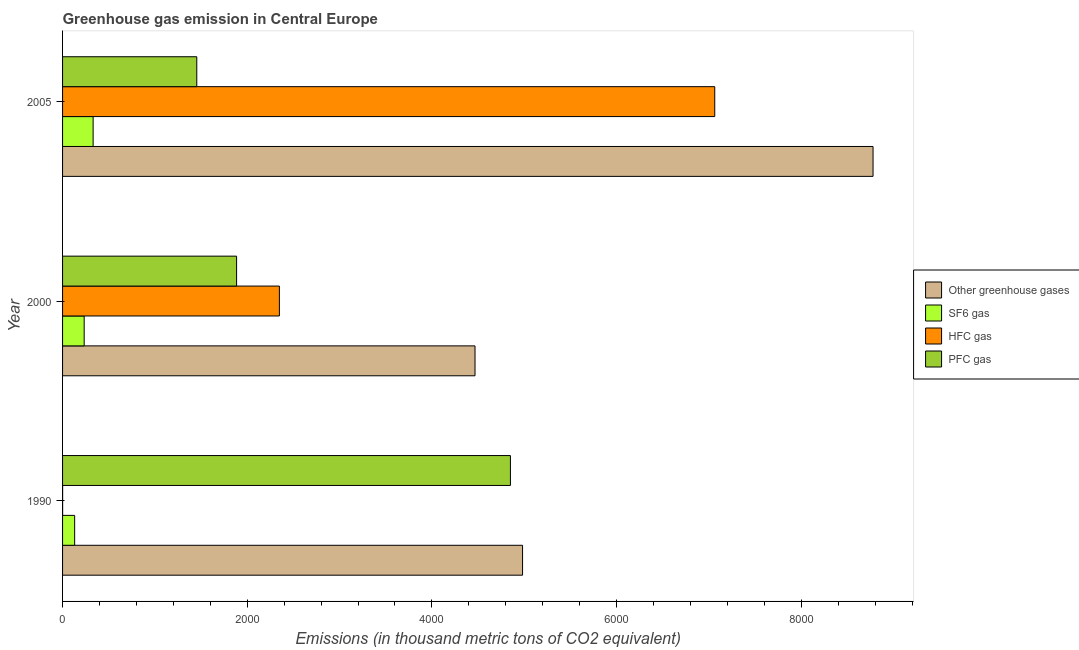How many different coloured bars are there?
Make the answer very short. 4. Are the number of bars on each tick of the Y-axis equal?
Your response must be concise. Yes. How many bars are there on the 2nd tick from the bottom?
Keep it short and to the point. 4. In how many cases, is the number of bars for a given year not equal to the number of legend labels?
Offer a very short reply. 0. What is the emission of hfc gas in 1990?
Your answer should be very brief. 0.5. Across all years, what is the maximum emission of sf6 gas?
Ensure brevity in your answer.  330.99. Across all years, what is the minimum emission of pfc gas?
Ensure brevity in your answer.  1453.6. In which year was the emission of hfc gas maximum?
Ensure brevity in your answer.  2005. What is the total emission of sf6 gas in the graph?
Offer a terse response. 695.99. What is the difference between the emission of greenhouse gases in 1990 and that in 2000?
Your answer should be compact. 515. What is the difference between the emission of sf6 gas in 2000 and the emission of greenhouse gases in 2005?
Provide a succinct answer. -8543.6. What is the average emission of hfc gas per year?
Ensure brevity in your answer.  3137.33. In the year 2000, what is the difference between the emission of hfc gas and emission of greenhouse gases?
Give a very brief answer. -2118.7. What is the ratio of the emission of sf6 gas in 1990 to that in 2005?
Keep it short and to the point. 0.4. What is the difference between the highest and the second highest emission of pfc gas?
Your response must be concise. 2965.7. What is the difference between the highest and the lowest emission of pfc gas?
Your answer should be compact. 3396.8. Is the sum of the emission of pfc gas in 1990 and 2000 greater than the maximum emission of hfc gas across all years?
Your answer should be very brief. No. Is it the case that in every year, the sum of the emission of greenhouse gases and emission of sf6 gas is greater than the sum of emission of pfc gas and emission of hfc gas?
Your answer should be very brief. Yes. What does the 2nd bar from the top in 1990 represents?
Provide a succinct answer. HFC gas. What does the 3rd bar from the bottom in 1990 represents?
Make the answer very short. HFC gas. Is it the case that in every year, the sum of the emission of greenhouse gases and emission of sf6 gas is greater than the emission of hfc gas?
Your answer should be very brief. Yes. How many years are there in the graph?
Your response must be concise. 3. Does the graph contain any zero values?
Provide a succinct answer. No. Does the graph contain grids?
Your answer should be very brief. No. How are the legend labels stacked?
Make the answer very short. Vertical. What is the title of the graph?
Offer a very short reply. Greenhouse gas emission in Central Europe. Does "UNDP" appear as one of the legend labels in the graph?
Give a very brief answer. No. What is the label or title of the X-axis?
Offer a terse response. Emissions (in thousand metric tons of CO2 equivalent). What is the label or title of the Y-axis?
Provide a short and direct response. Year. What is the Emissions (in thousand metric tons of CO2 equivalent) of Other greenhouse gases in 1990?
Your response must be concise. 4981.9. What is the Emissions (in thousand metric tons of CO2 equivalent) of SF6 gas in 1990?
Your answer should be compact. 131. What is the Emissions (in thousand metric tons of CO2 equivalent) of HFC gas in 1990?
Ensure brevity in your answer.  0.5. What is the Emissions (in thousand metric tons of CO2 equivalent) in PFC gas in 1990?
Your answer should be compact. 4850.4. What is the Emissions (in thousand metric tons of CO2 equivalent) in Other greenhouse gases in 2000?
Your response must be concise. 4466.9. What is the Emissions (in thousand metric tons of CO2 equivalent) in SF6 gas in 2000?
Your answer should be very brief. 234. What is the Emissions (in thousand metric tons of CO2 equivalent) in HFC gas in 2000?
Your answer should be compact. 2348.2. What is the Emissions (in thousand metric tons of CO2 equivalent) of PFC gas in 2000?
Make the answer very short. 1884.7. What is the Emissions (in thousand metric tons of CO2 equivalent) in Other greenhouse gases in 2005?
Provide a succinct answer. 8777.6. What is the Emissions (in thousand metric tons of CO2 equivalent) of SF6 gas in 2005?
Keep it short and to the point. 330.99. What is the Emissions (in thousand metric tons of CO2 equivalent) of HFC gas in 2005?
Give a very brief answer. 7063.3. What is the Emissions (in thousand metric tons of CO2 equivalent) of PFC gas in 2005?
Provide a short and direct response. 1453.6. Across all years, what is the maximum Emissions (in thousand metric tons of CO2 equivalent) in Other greenhouse gases?
Ensure brevity in your answer.  8777.6. Across all years, what is the maximum Emissions (in thousand metric tons of CO2 equivalent) in SF6 gas?
Your answer should be very brief. 330.99. Across all years, what is the maximum Emissions (in thousand metric tons of CO2 equivalent) in HFC gas?
Offer a very short reply. 7063.3. Across all years, what is the maximum Emissions (in thousand metric tons of CO2 equivalent) in PFC gas?
Your answer should be very brief. 4850.4. Across all years, what is the minimum Emissions (in thousand metric tons of CO2 equivalent) of Other greenhouse gases?
Keep it short and to the point. 4466.9. Across all years, what is the minimum Emissions (in thousand metric tons of CO2 equivalent) in SF6 gas?
Your answer should be very brief. 131. Across all years, what is the minimum Emissions (in thousand metric tons of CO2 equivalent) of PFC gas?
Your response must be concise. 1453.6. What is the total Emissions (in thousand metric tons of CO2 equivalent) in Other greenhouse gases in the graph?
Make the answer very short. 1.82e+04. What is the total Emissions (in thousand metric tons of CO2 equivalent) in SF6 gas in the graph?
Offer a terse response. 695.99. What is the total Emissions (in thousand metric tons of CO2 equivalent) of HFC gas in the graph?
Make the answer very short. 9412. What is the total Emissions (in thousand metric tons of CO2 equivalent) in PFC gas in the graph?
Give a very brief answer. 8188.7. What is the difference between the Emissions (in thousand metric tons of CO2 equivalent) in Other greenhouse gases in 1990 and that in 2000?
Offer a very short reply. 515. What is the difference between the Emissions (in thousand metric tons of CO2 equivalent) in SF6 gas in 1990 and that in 2000?
Keep it short and to the point. -103. What is the difference between the Emissions (in thousand metric tons of CO2 equivalent) of HFC gas in 1990 and that in 2000?
Make the answer very short. -2347.7. What is the difference between the Emissions (in thousand metric tons of CO2 equivalent) of PFC gas in 1990 and that in 2000?
Offer a very short reply. 2965.7. What is the difference between the Emissions (in thousand metric tons of CO2 equivalent) in Other greenhouse gases in 1990 and that in 2005?
Make the answer very short. -3795.7. What is the difference between the Emissions (in thousand metric tons of CO2 equivalent) in SF6 gas in 1990 and that in 2005?
Give a very brief answer. -199.99. What is the difference between the Emissions (in thousand metric tons of CO2 equivalent) of HFC gas in 1990 and that in 2005?
Make the answer very short. -7062.8. What is the difference between the Emissions (in thousand metric tons of CO2 equivalent) of PFC gas in 1990 and that in 2005?
Your answer should be very brief. 3396.8. What is the difference between the Emissions (in thousand metric tons of CO2 equivalent) in Other greenhouse gases in 2000 and that in 2005?
Provide a succinct answer. -4310.7. What is the difference between the Emissions (in thousand metric tons of CO2 equivalent) in SF6 gas in 2000 and that in 2005?
Make the answer very short. -96.99. What is the difference between the Emissions (in thousand metric tons of CO2 equivalent) in HFC gas in 2000 and that in 2005?
Provide a succinct answer. -4715.1. What is the difference between the Emissions (in thousand metric tons of CO2 equivalent) in PFC gas in 2000 and that in 2005?
Keep it short and to the point. 431.1. What is the difference between the Emissions (in thousand metric tons of CO2 equivalent) of Other greenhouse gases in 1990 and the Emissions (in thousand metric tons of CO2 equivalent) of SF6 gas in 2000?
Your answer should be compact. 4747.9. What is the difference between the Emissions (in thousand metric tons of CO2 equivalent) of Other greenhouse gases in 1990 and the Emissions (in thousand metric tons of CO2 equivalent) of HFC gas in 2000?
Ensure brevity in your answer.  2633.7. What is the difference between the Emissions (in thousand metric tons of CO2 equivalent) in Other greenhouse gases in 1990 and the Emissions (in thousand metric tons of CO2 equivalent) in PFC gas in 2000?
Ensure brevity in your answer.  3097.2. What is the difference between the Emissions (in thousand metric tons of CO2 equivalent) of SF6 gas in 1990 and the Emissions (in thousand metric tons of CO2 equivalent) of HFC gas in 2000?
Provide a succinct answer. -2217.2. What is the difference between the Emissions (in thousand metric tons of CO2 equivalent) of SF6 gas in 1990 and the Emissions (in thousand metric tons of CO2 equivalent) of PFC gas in 2000?
Ensure brevity in your answer.  -1753.7. What is the difference between the Emissions (in thousand metric tons of CO2 equivalent) of HFC gas in 1990 and the Emissions (in thousand metric tons of CO2 equivalent) of PFC gas in 2000?
Your answer should be compact. -1884.2. What is the difference between the Emissions (in thousand metric tons of CO2 equivalent) in Other greenhouse gases in 1990 and the Emissions (in thousand metric tons of CO2 equivalent) in SF6 gas in 2005?
Offer a terse response. 4650.91. What is the difference between the Emissions (in thousand metric tons of CO2 equivalent) of Other greenhouse gases in 1990 and the Emissions (in thousand metric tons of CO2 equivalent) of HFC gas in 2005?
Provide a short and direct response. -2081.4. What is the difference between the Emissions (in thousand metric tons of CO2 equivalent) of Other greenhouse gases in 1990 and the Emissions (in thousand metric tons of CO2 equivalent) of PFC gas in 2005?
Give a very brief answer. 3528.3. What is the difference between the Emissions (in thousand metric tons of CO2 equivalent) in SF6 gas in 1990 and the Emissions (in thousand metric tons of CO2 equivalent) in HFC gas in 2005?
Make the answer very short. -6932.3. What is the difference between the Emissions (in thousand metric tons of CO2 equivalent) of SF6 gas in 1990 and the Emissions (in thousand metric tons of CO2 equivalent) of PFC gas in 2005?
Your response must be concise. -1322.6. What is the difference between the Emissions (in thousand metric tons of CO2 equivalent) of HFC gas in 1990 and the Emissions (in thousand metric tons of CO2 equivalent) of PFC gas in 2005?
Your response must be concise. -1453.1. What is the difference between the Emissions (in thousand metric tons of CO2 equivalent) of Other greenhouse gases in 2000 and the Emissions (in thousand metric tons of CO2 equivalent) of SF6 gas in 2005?
Keep it short and to the point. 4135.91. What is the difference between the Emissions (in thousand metric tons of CO2 equivalent) in Other greenhouse gases in 2000 and the Emissions (in thousand metric tons of CO2 equivalent) in HFC gas in 2005?
Your response must be concise. -2596.4. What is the difference between the Emissions (in thousand metric tons of CO2 equivalent) in Other greenhouse gases in 2000 and the Emissions (in thousand metric tons of CO2 equivalent) in PFC gas in 2005?
Your answer should be very brief. 3013.3. What is the difference between the Emissions (in thousand metric tons of CO2 equivalent) of SF6 gas in 2000 and the Emissions (in thousand metric tons of CO2 equivalent) of HFC gas in 2005?
Your response must be concise. -6829.3. What is the difference between the Emissions (in thousand metric tons of CO2 equivalent) in SF6 gas in 2000 and the Emissions (in thousand metric tons of CO2 equivalent) in PFC gas in 2005?
Provide a short and direct response. -1219.6. What is the difference between the Emissions (in thousand metric tons of CO2 equivalent) of HFC gas in 2000 and the Emissions (in thousand metric tons of CO2 equivalent) of PFC gas in 2005?
Keep it short and to the point. 894.6. What is the average Emissions (in thousand metric tons of CO2 equivalent) of Other greenhouse gases per year?
Offer a terse response. 6075.47. What is the average Emissions (in thousand metric tons of CO2 equivalent) in SF6 gas per year?
Your answer should be very brief. 232. What is the average Emissions (in thousand metric tons of CO2 equivalent) of HFC gas per year?
Provide a short and direct response. 3137.33. What is the average Emissions (in thousand metric tons of CO2 equivalent) of PFC gas per year?
Make the answer very short. 2729.57. In the year 1990, what is the difference between the Emissions (in thousand metric tons of CO2 equivalent) of Other greenhouse gases and Emissions (in thousand metric tons of CO2 equivalent) of SF6 gas?
Ensure brevity in your answer.  4850.9. In the year 1990, what is the difference between the Emissions (in thousand metric tons of CO2 equivalent) in Other greenhouse gases and Emissions (in thousand metric tons of CO2 equivalent) in HFC gas?
Provide a short and direct response. 4981.4. In the year 1990, what is the difference between the Emissions (in thousand metric tons of CO2 equivalent) in Other greenhouse gases and Emissions (in thousand metric tons of CO2 equivalent) in PFC gas?
Ensure brevity in your answer.  131.5. In the year 1990, what is the difference between the Emissions (in thousand metric tons of CO2 equivalent) in SF6 gas and Emissions (in thousand metric tons of CO2 equivalent) in HFC gas?
Provide a short and direct response. 130.5. In the year 1990, what is the difference between the Emissions (in thousand metric tons of CO2 equivalent) in SF6 gas and Emissions (in thousand metric tons of CO2 equivalent) in PFC gas?
Your answer should be compact. -4719.4. In the year 1990, what is the difference between the Emissions (in thousand metric tons of CO2 equivalent) in HFC gas and Emissions (in thousand metric tons of CO2 equivalent) in PFC gas?
Ensure brevity in your answer.  -4849.9. In the year 2000, what is the difference between the Emissions (in thousand metric tons of CO2 equivalent) of Other greenhouse gases and Emissions (in thousand metric tons of CO2 equivalent) of SF6 gas?
Your answer should be very brief. 4232.9. In the year 2000, what is the difference between the Emissions (in thousand metric tons of CO2 equivalent) of Other greenhouse gases and Emissions (in thousand metric tons of CO2 equivalent) of HFC gas?
Provide a succinct answer. 2118.7. In the year 2000, what is the difference between the Emissions (in thousand metric tons of CO2 equivalent) of Other greenhouse gases and Emissions (in thousand metric tons of CO2 equivalent) of PFC gas?
Keep it short and to the point. 2582.2. In the year 2000, what is the difference between the Emissions (in thousand metric tons of CO2 equivalent) in SF6 gas and Emissions (in thousand metric tons of CO2 equivalent) in HFC gas?
Provide a succinct answer. -2114.2. In the year 2000, what is the difference between the Emissions (in thousand metric tons of CO2 equivalent) of SF6 gas and Emissions (in thousand metric tons of CO2 equivalent) of PFC gas?
Provide a short and direct response. -1650.7. In the year 2000, what is the difference between the Emissions (in thousand metric tons of CO2 equivalent) of HFC gas and Emissions (in thousand metric tons of CO2 equivalent) of PFC gas?
Ensure brevity in your answer.  463.5. In the year 2005, what is the difference between the Emissions (in thousand metric tons of CO2 equivalent) of Other greenhouse gases and Emissions (in thousand metric tons of CO2 equivalent) of SF6 gas?
Make the answer very short. 8446.61. In the year 2005, what is the difference between the Emissions (in thousand metric tons of CO2 equivalent) of Other greenhouse gases and Emissions (in thousand metric tons of CO2 equivalent) of HFC gas?
Your answer should be compact. 1714.3. In the year 2005, what is the difference between the Emissions (in thousand metric tons of CO2 equivalent) of Other greenhouse gases and Emissions (in thousand metric tons of CO2 equivalent) of PFC gas?
Provide a short and direct response. 7324. In the year 2005, what is the difference between the Emissions (in thousand metric tons of CO2 equivalent) in SF6 gas and Emissions (in thousand metric tons of CO2 equivalent) in HFC gas?
Your answer should be very brief. -6732.31. In the year 2005, what is the difference between the Emissions (in thousand metric tons of CO2 equivalent) in SF6 gas and Emissions (in thousand metric tons of CO2 equivalent) in PFC gas?
Your answer should be compact. -1122.61. In the year 2005, what is the difference between the Emissions (in thousand metric tons of CO2 equivalent) in HFC gas and Emissions (in thousand metric tons of CO2 equivalent) in PFC gas?
Ensure brevity in your answer.  5609.7. What is the ratio of the Emissions (in thousand metric tons of CO2 equivalent) in Other greenhouse gases in 1990 to that in 2000?
Your answer should be compact. 1.12. What is the ratio of the Emissions (in thousand metric tons of CO2 equivalent) in SF6 gas in 1990 to that in 2000?
Your answer should be compact. 0.56. What is the ratio of the Emissions (in thousand metric tons of CO2 equivalent) in PFC gas in 1990 to that in 2000?
Provide a succinct answer. 2.57. What is the ratio of the Emissions (in thousand metric tons of CO2 equivalent) of Other greenhouse gases in 1990 to that in 2005?
Provide a succinct answer. 0.57. What is the ratio of the Emissions (in thousand metric tons of CO2 equivalent) in SF6 gas in 1990 to that in 2005?
Provide a short and direct response. 0.4. What is the ratio of the Emissions (in thousand metric tons of CO2 equivalent) of HFC gas in 1990 to that in 2005?
Offer a very short reply. 0. What is the ratio of the Emissions (in thousand metric tons of CO2 equivalent) in PFC gas in 1990 to that in 2005?
Offer a very short reply. 3.34. What is the ratio of the Emissions (in thousand metric tons of CO2 equivalent) of Other greenhouse gases in 2000 to that in 2005?
Give a very brief answer. 0.51. What is the ratio of the Emissions (in thousand metric tons of CO2 equivalent) in SF6 gas in 2000 to that in 2005?
Make the answer very short. 0.71. What is the ratio of the Emissions (in thousand metric tons of CO2 equivalent) in HFC gas in 2000 to that in 2005?
Provide a succinct answer. 0.33. What is the ratio of the Emissions (in thousand metric tons of CO2 equivalent) in PFC gas in 2000 to that in 2005?
Provide a short and direct response. 1.3. What is the difference between the highest and the second highest Emissions (in thousand metric tons of CO2 equivalent) in Other greenhouse gases?
Your answer should be compact. 3795.7. What is the difference between the highest and the second highest Emissions (in thousand metric tons of CO2 equivalent) of SF6 gas?
Your answer should be compact. 96.99. What is the difference between the highest and the second highest Emissions (in thousand metric tons of CO2 equivalent) in HFC gas?
Provide a succinct answer. 4715.1. What is the difference between the highest and the second highest Emissions (in thousand metric tons of CO2 equivalent) of PFC gas?
Keep it short and to the point. 2965.7. What is the difference between the highest and the lowest Emissions (in thousand metric tons of CO2 equivalent) of Other greenhouse gases?
Your answer should be compact. 4310.7. What is the difference between the highest and the lowest Emissions (in thousand metric tons of CO2 equivalent) of SF6 gas?
Give a very brief answer. 199.99. What is the difference between the highest and the lowest Emissions (in thousand metric tons of CO2 equivalent) of HFC gas?
Provide a short and direct response. 7062.8. What is the difference between the highest and the lowest Emissions (in thousand metric tons of CO2 equivalent) of PFC gas?
Ensure brevity in your answer.  3396.8. 